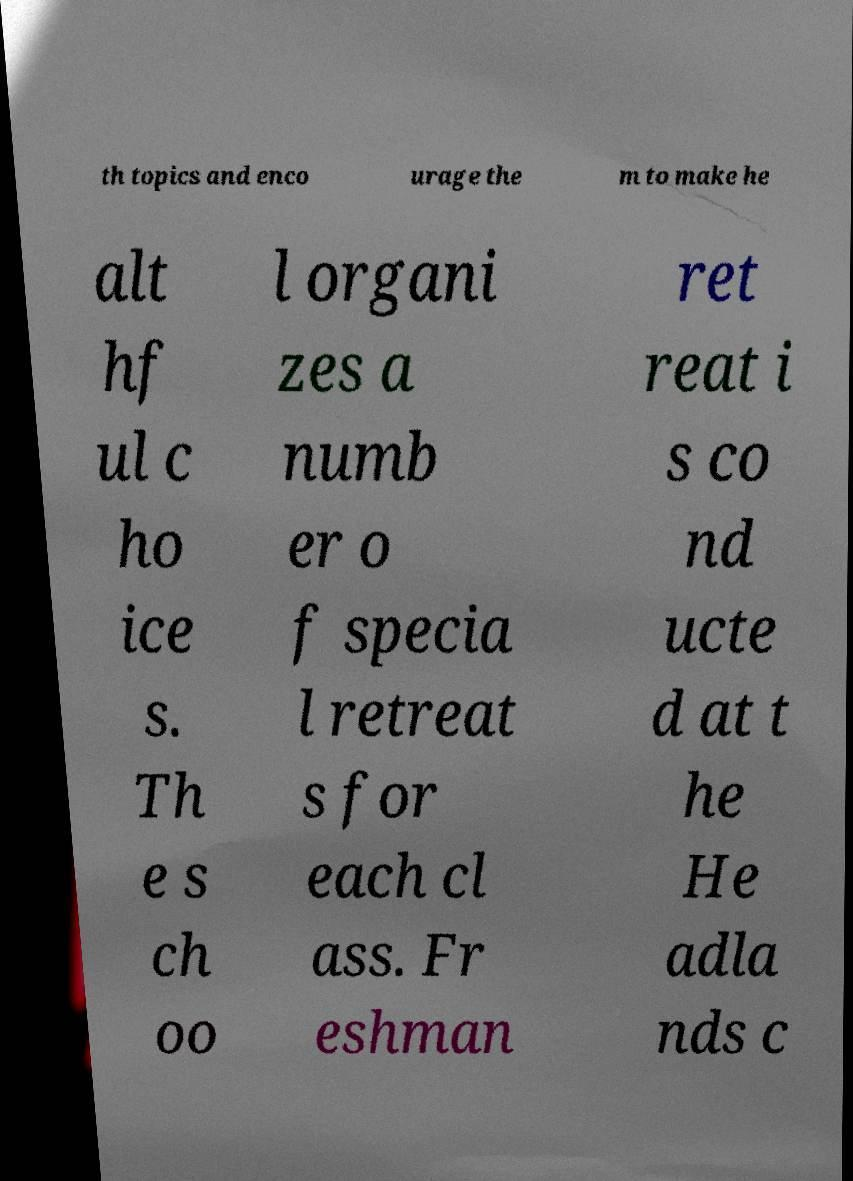Could you assist in decoding the text presented in this image and type it out clearly? th topics and enco urage the m to make he alt hf ul c ho ice s. Th e s ch oo l organi zes a numb er o f specia l retreat s for each cl ass. Fr eshman ret reat i s co nd ucte d at t he He adla nds c 